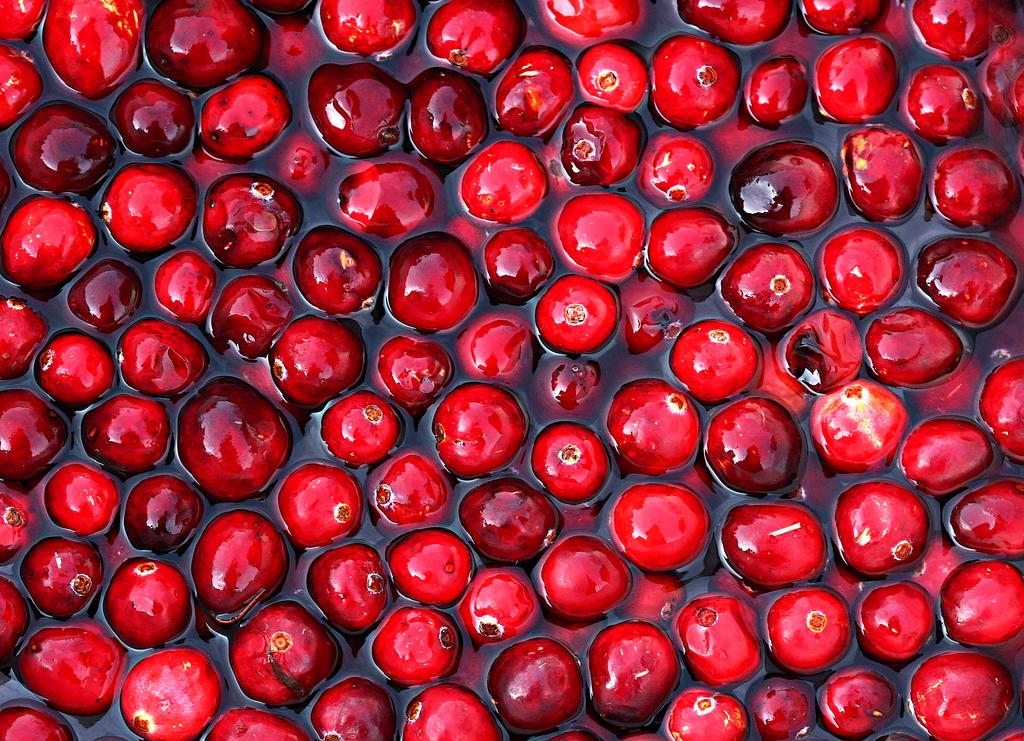What type of food can be seen in the image? There are fruits in the image. Where are the fruits located? The fruits are in the water. How many people are depicted in the image? There are no people present in the image; it features fruits in the water. What type of animals can be seen interacting with the fruits in the image? There are no animals, such as frogs, present in the image; it only features fruits in the water. 